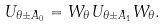Convert formula to latex. <formula><loc_0><loc_0><loc_500><loc_500>U _ { { \theta \pm } A _ { 0 } } = W _ { \theta } U _ { { \theta \pm } A _ { 1 } } W _ { \theta } .</formula> 